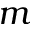<formula> <loc_0><loc_0><loc_500><loc_500>m</formula> 